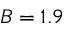<formula> <loc_0><loc_0><loc_500><loc_500>B = 1 . 9</formula> 